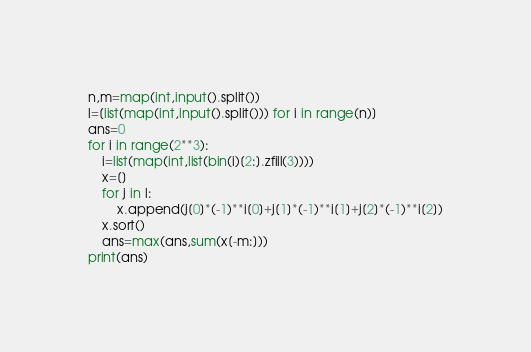Convert code to text. <code><loc_0><loc_0><loc_500><loc_500><_Python_>n,m=map(int,input().split())
l=[list(map(int,input().split())) for i in range(n)]
ans=0
for i in range(2**3):
    i=list(map(int,list(bin(i)[2:].zfill(3))))
    x=[]
    for j in l:
        x.append(j[0]*(-1)**i[0]+j[1]*(-1)**i[1]+j[2]*(-1)**i[2])
    x.sort()
    ans=max(ans,sum(x[-m:]))
print(ans)</code> 